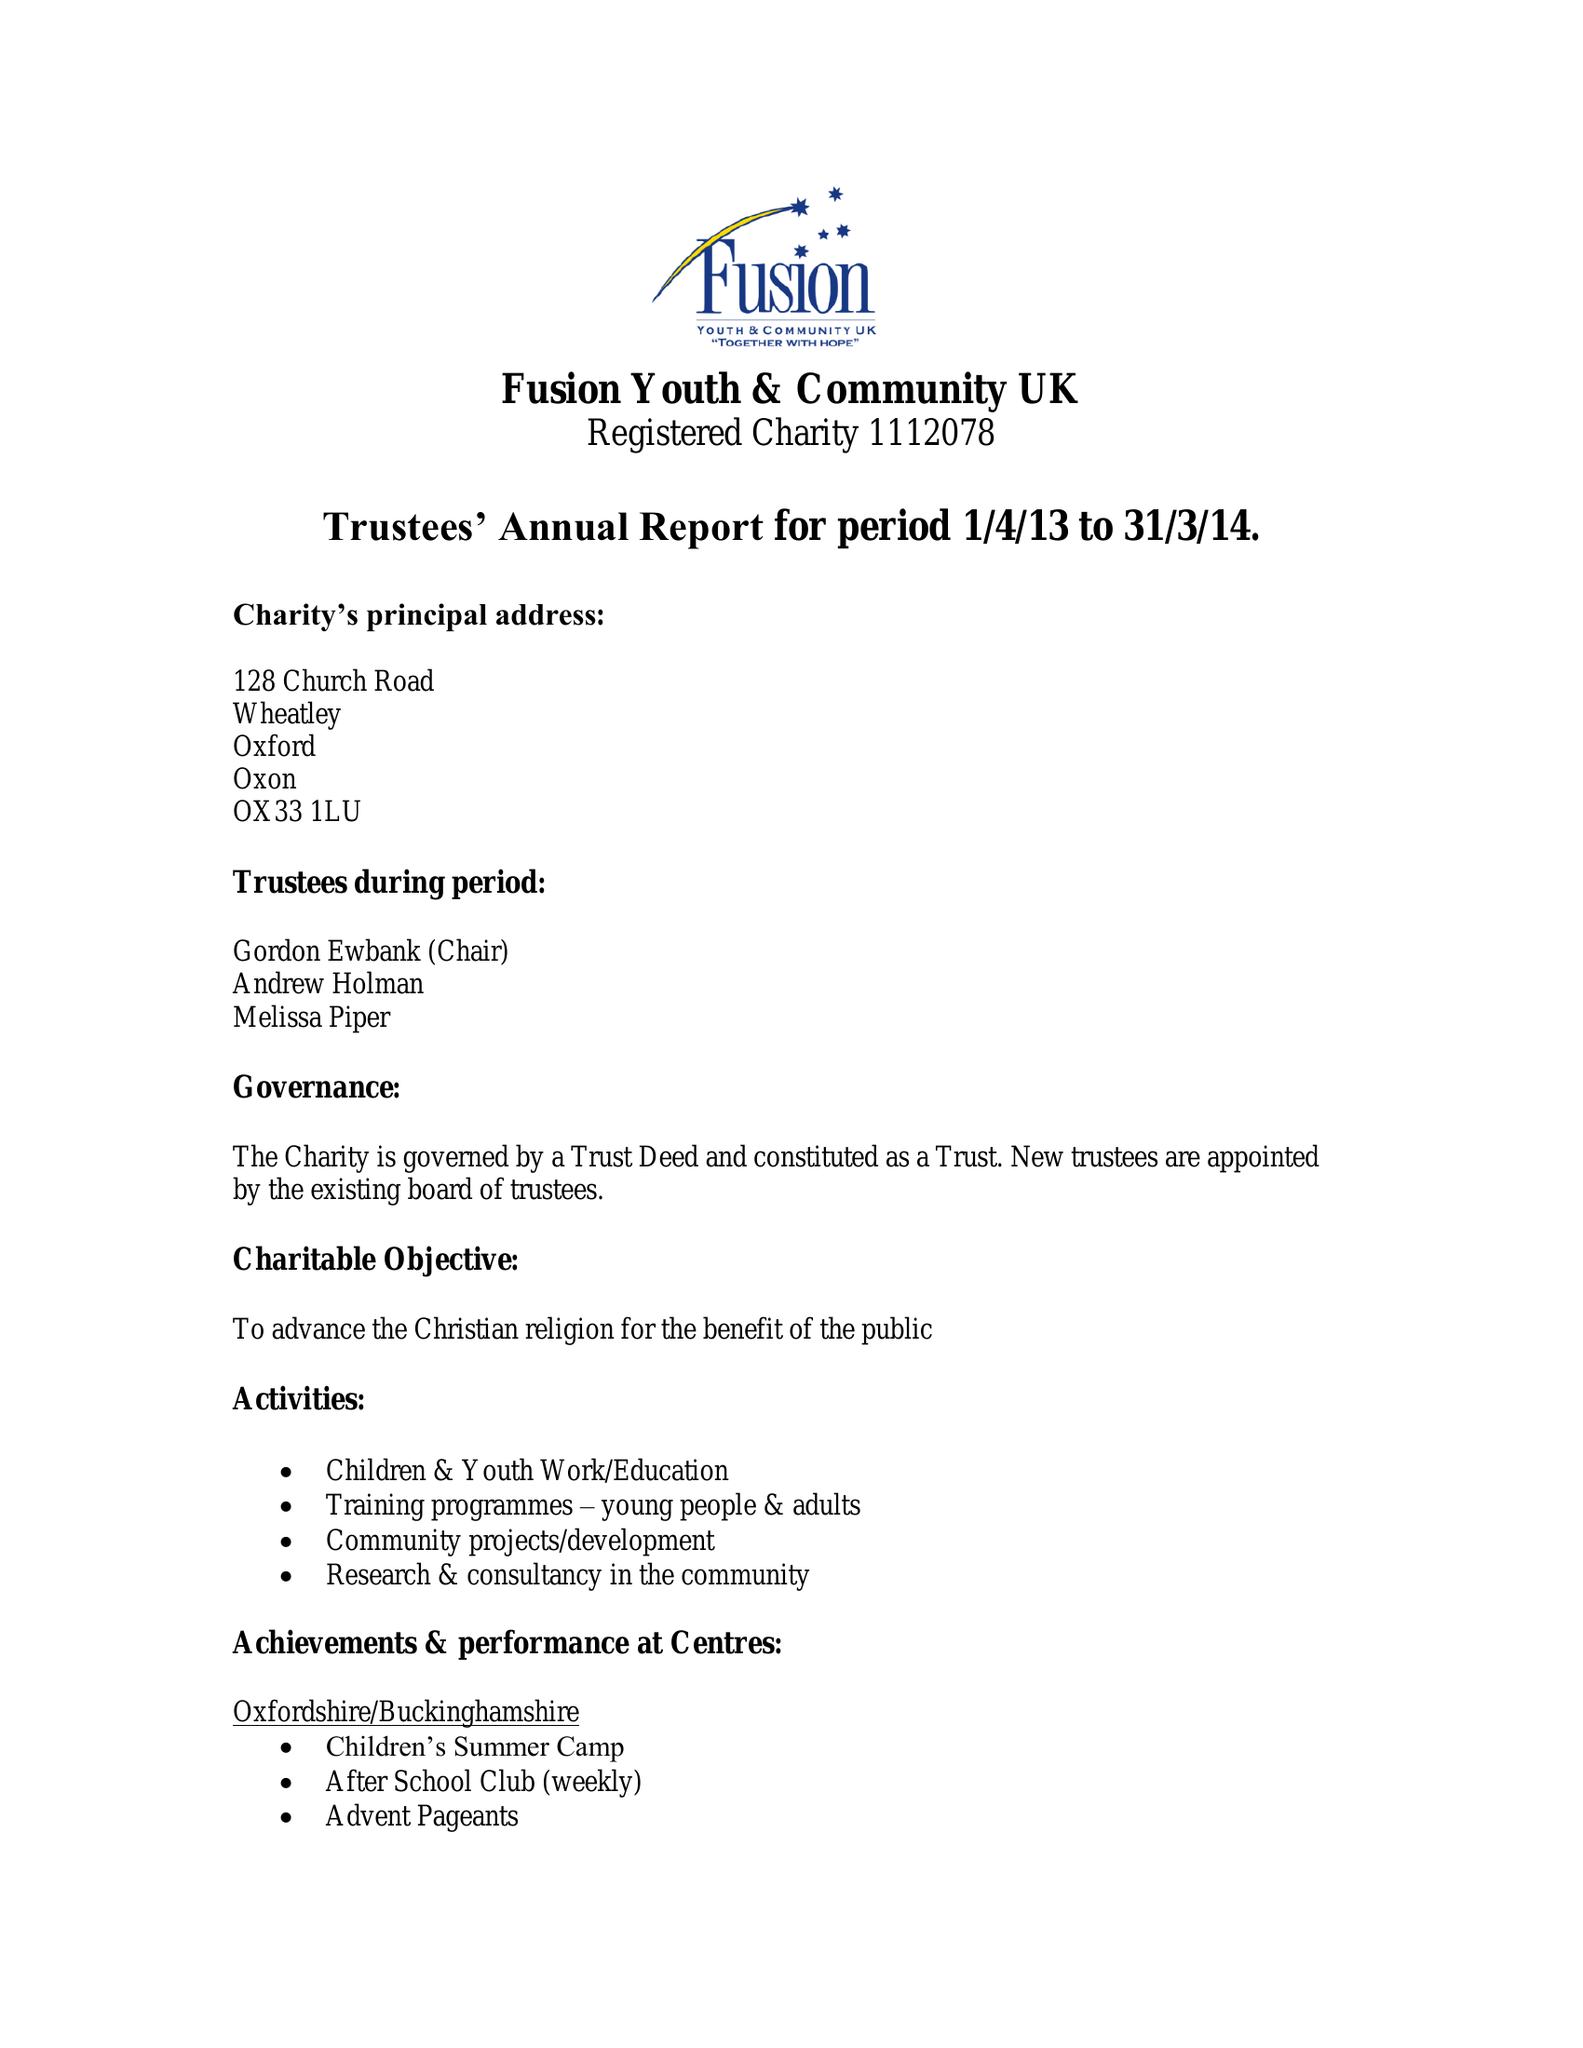What is the value for the charity_number?
Answer the question using a single word or phrase. 1112078 